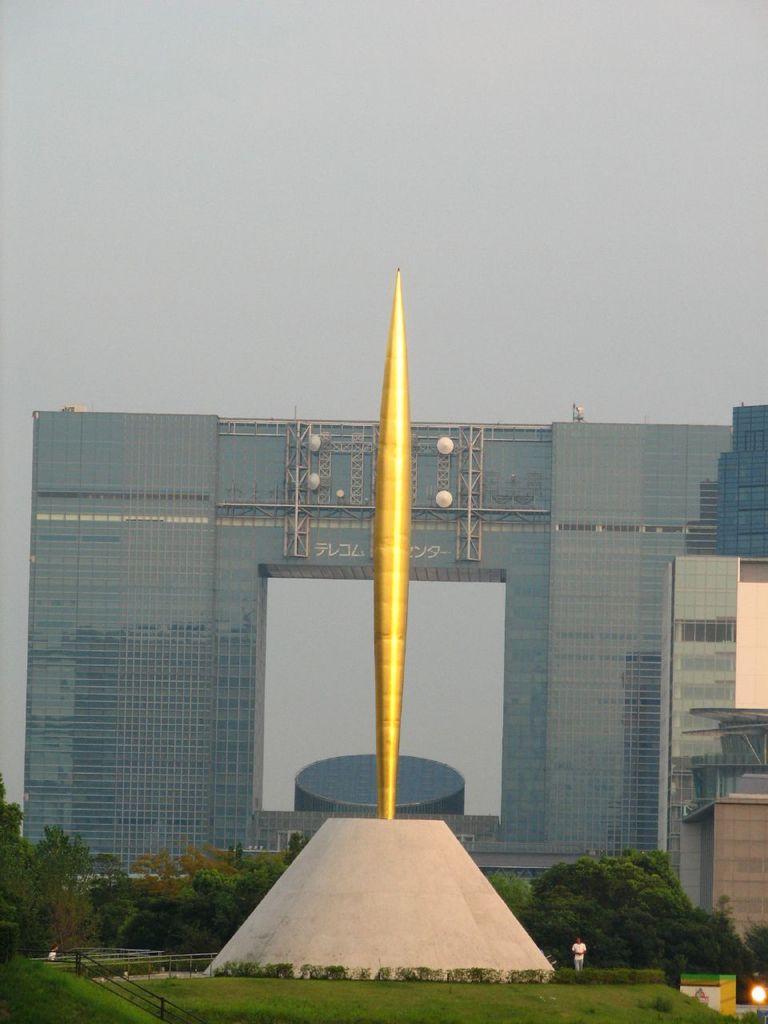Describe this image in one or two sentences. This is an outside view. On the ground, I can see the grass. In the middle of the image there is a pole. In the background there are some trees and buildings. At the top of the image I can see the sky. At the bottom, I can see a person walking on the ground. 